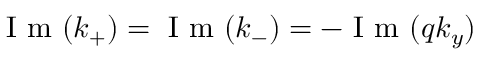Convert formula to latex. <formula><loc_0><loc_0><loc_500><loc_500>I m ( k _ { + } ) = I m ( k _ { - } ) = - I m ( q k _ { y } )</formula> 